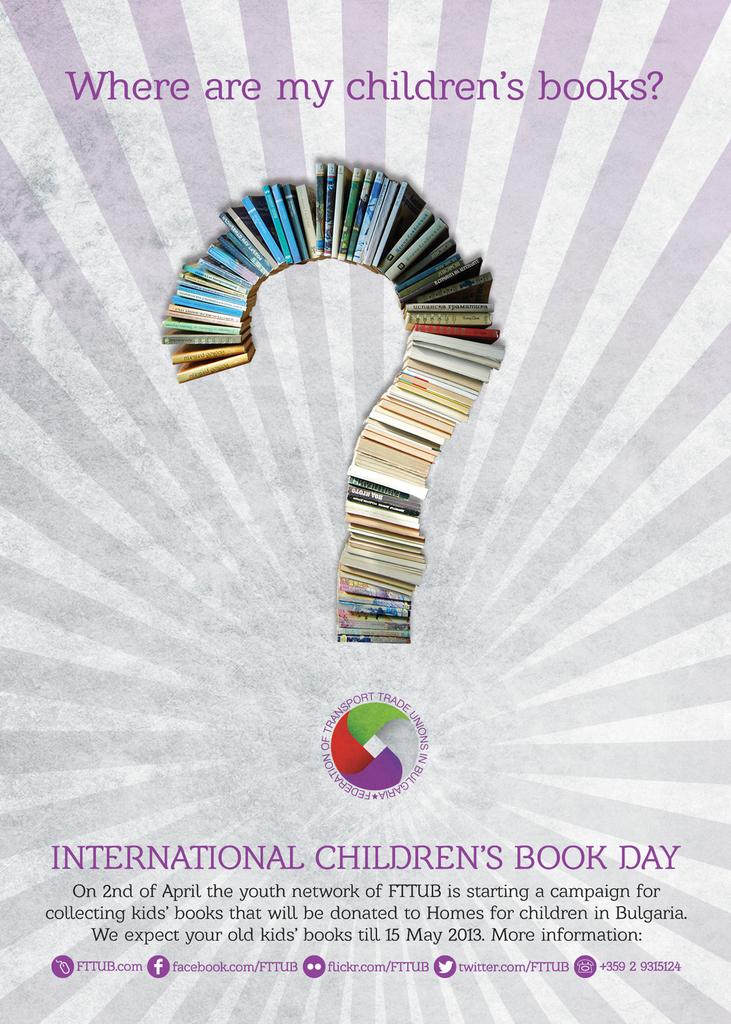What question is asked at the top of the poster?
Provide a succinct answer. Where are my children's books?. What type of day is it according to the poster?
Your answer should be very brief. International children's book day. 